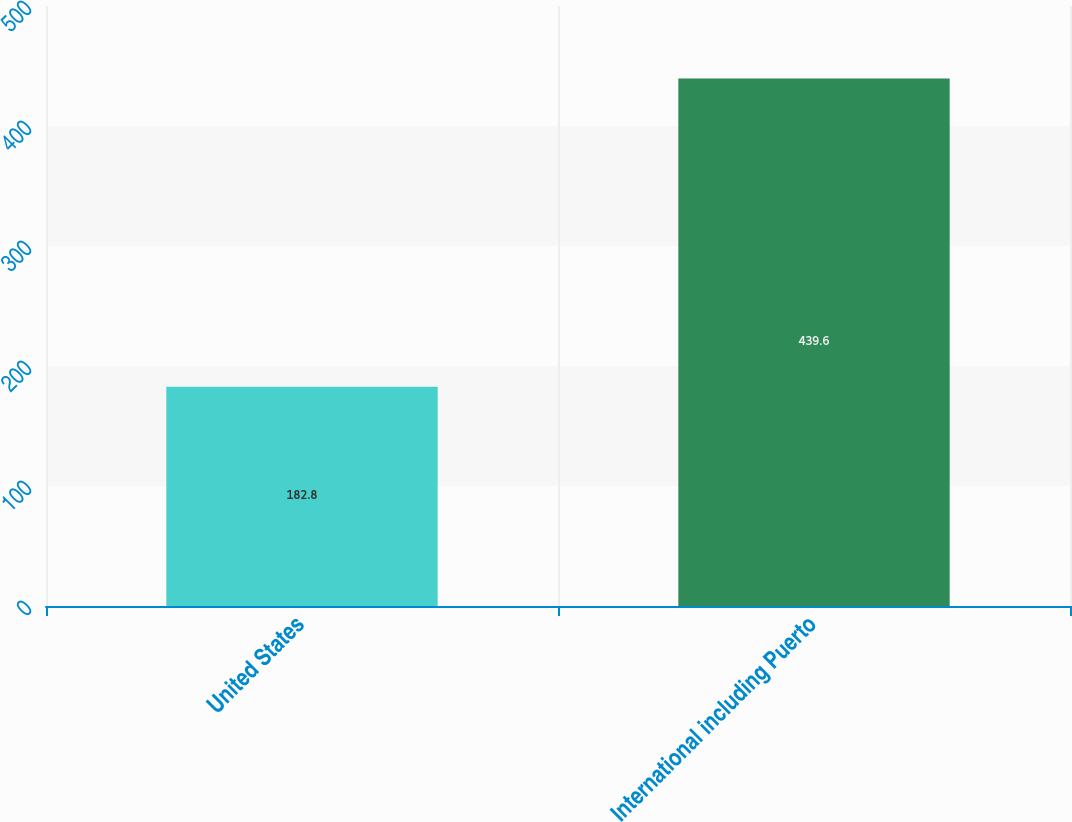Convert chart to OTSL. <chart><loc_0><loc_0><loc_500><loc_500><bar_chart><fcel>United States<fcel>International including Puerto<nl><fcel>182.8<fcel>439.6<nl></chart> 